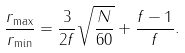Convert formula to latex. <formula><loc_0><loc_0><loc_500><loc_500>\frac { r _ { \max } } { r _ { \min } } = \frac { 3 } { 2 f } \sqrt { \frac { N } { 6 0 } } + \frac { f - 1 } { f } .</formula> 